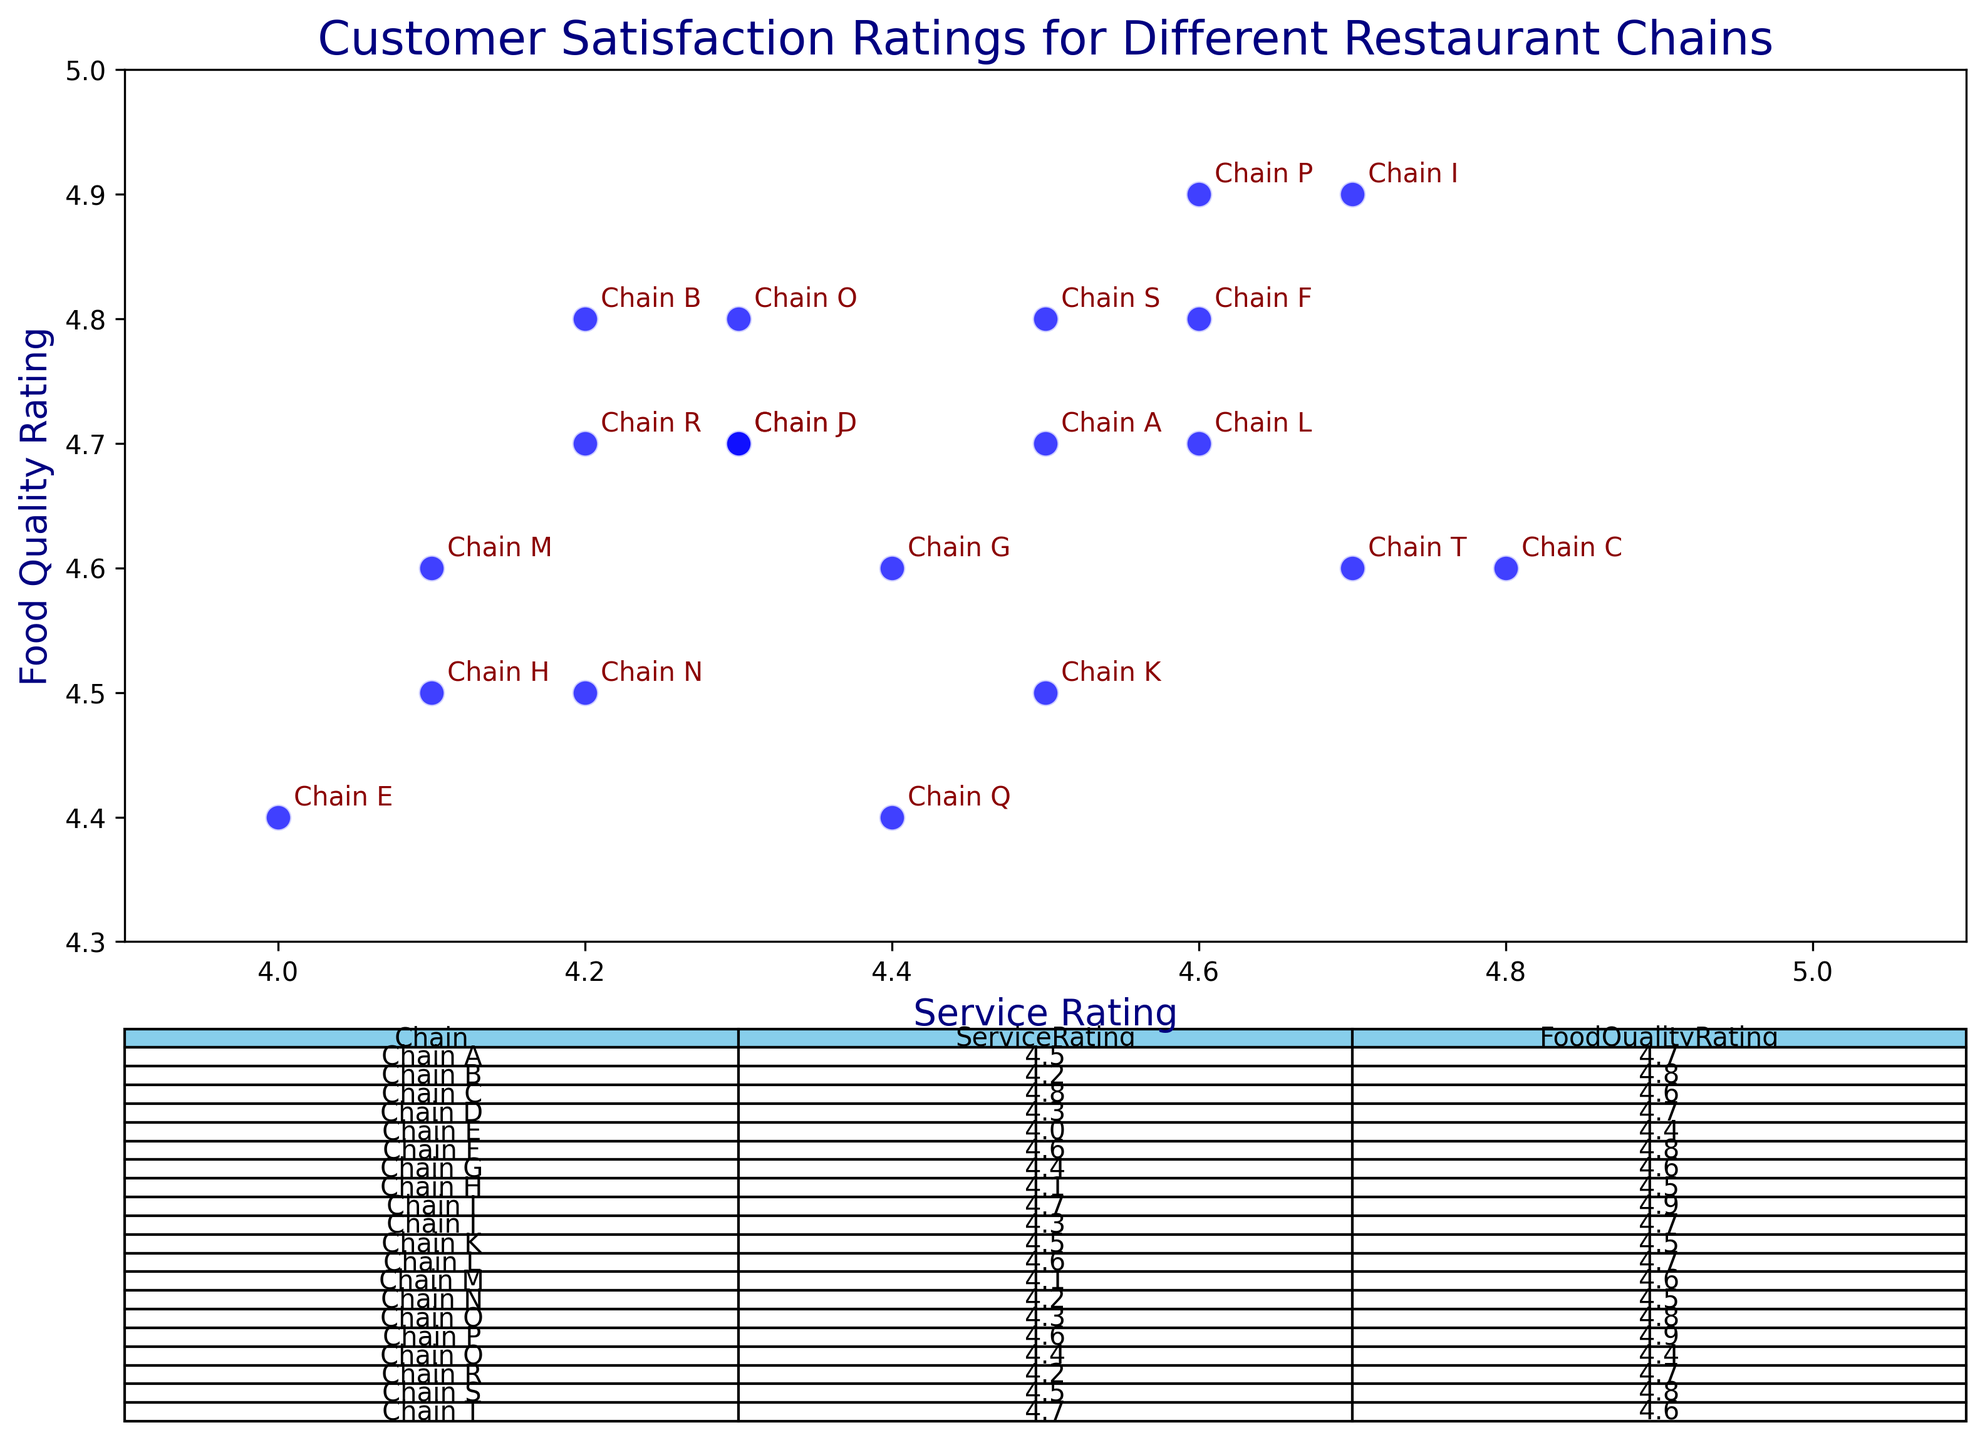What is the name of the chain with the highest Food Quality Rating? The highest Food Quality Rating is 4.9. By looking at the table, Chain I has a Food Quality Rating of 4.9.
Answer: Chain I Which chain has the lowest Service Rating? The lowest Service Rating is 4.0. By referring to the table, Chain E has a Service Rating of 4.0.
Answer: Chain E Which two chains have the same Food Quality Rating of 4.9? By looking at the Food Quality Rating column, Chains I and P both have a rating of 4.9.
Answer: Chains I and P Which chain has a higher Service Rating, Chain A or Chain H? Chain A has a Service Rating of 4.5, while Chain H has a Service Rating of 4.1. Therefore, Chain A has a higher Service Rating than Chain H.
Answer: Chain A What is the average Service Rating for Chains A, B, and C? The Service Ratings for Chains A, B, and C are 4.5, 4.2, and 4.8, respectively. Summing them gives 4.5 + 4.2 + 4.8 = 13.5. The average is 13.5 / 3 = 4.5.
Answer: 4.5 What is the difference in Food Quality Rating between Chain F and Chain E? Chain F has a Food Quality Rating of 4.8, and Chain E has a rating of 4.4. The difference is 4.8 - 4.4 = 0.4.
Answer: 0.4 Which chains have both Service Rating and Food Quality Rating above 4.5? Chains C, F, I, L, and P all have both Service Rating and Food Quality Rating above 4.5.
Answer: Chains C, F, I, L, and P Which chain has a higher Food Quality Rating difference between Chains N and M? Chain N has a Food Quality Rating of 4.5 while Chain M has a Food Quality Rating of 4.6. The difference is 4.6 - 4.5 = 0.1 in favor of Chain M.
Answer: Chain M 